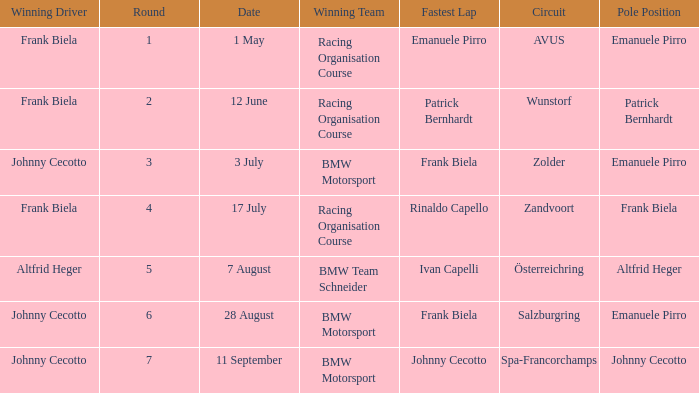Give me the full table as a dictionary. {'header': ['Winning Driver', 'Round', 'Date', 'Winning Team', 'Fastest Lap', 'Circuit', 'Pole Position'], 'rows': [['Frank Biela', '1', '1 May', 'Racing Organisation Course', 'Emanuele Pirro', 'AVUS', 'Emanuele Pirro'], ['Frank Biela', '2', '12 June', 'Racing Organisation Course', 'Patrick Bernhardt', 'Wunstorf', 'Patrick Bernhardt'], ['Johnny Cecotto', '3', '3 July', 'BMW Motorsport', 'Frank Biela', 'Zolder', 'Emanuele Pirro'], ['Frank Biela', '4', '17 July', 'Racing Organisation Course', 'Rinaldo Capello', 'Zandvoort', 'Frank Biela'], ['Altfrid Heger', '5', '7 August', 'BMW Team Schneider', 'Ivan Capelli', 'Österreichring', 'Altfrid Heger'], ['Johnny Cecotto', '6', '28 August', 'BMW Motorsport', 'Frank Biela', 'Salzburgring', 'Emanuele Pirro'], ['Johnny Cecotto', '7', '11 September', 'BMW Motorsport', 'Johnny Cecotto', 'Spa-Francorchamps', 'Johnny Cecotto']]} Who had pole position in round 7? Johnny Cecotto. 